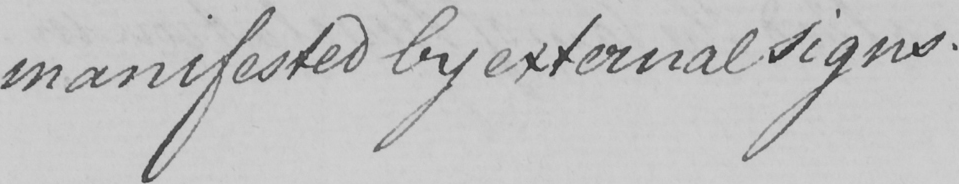Please provide the text content of this handwritten line. manifested by external signs . 